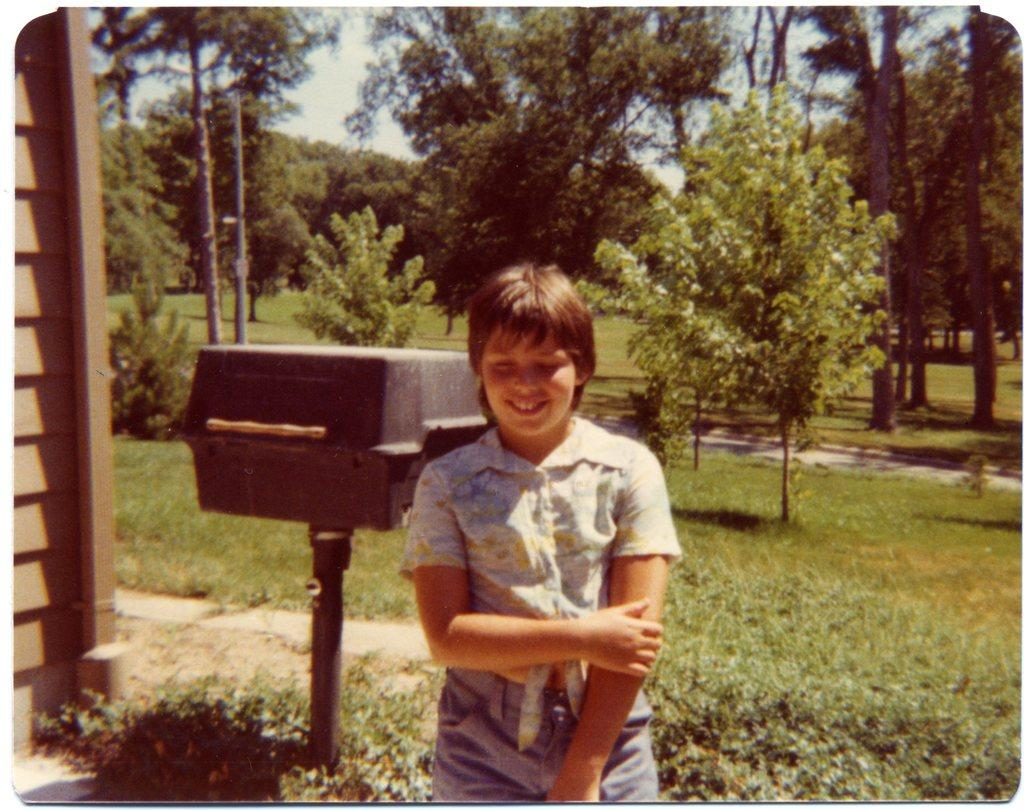What is the person in the image doing? The person is standing and smiling in the image. What type of terrain is visible at the bottom of the image? There is grass at the bottom of the image. What can be seen in the background of the image? There are trees in the background of the image. What is visible at the top of the image? The sky is visible at the top of the image. How many wrens are perched on the person's shoulder in the image? There are no wrens present in the image. What type of balance does the person exhibit in the image? The person is standing still and smiling, so there is no specific balance being demonstrated. 